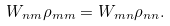Convert formula to latex. <formula><loc_0><loc_0><loc_500><loc_500>W _ { n m } \rho _ { m m } = W _ { m n } \rho _ { n n } .</formula> 